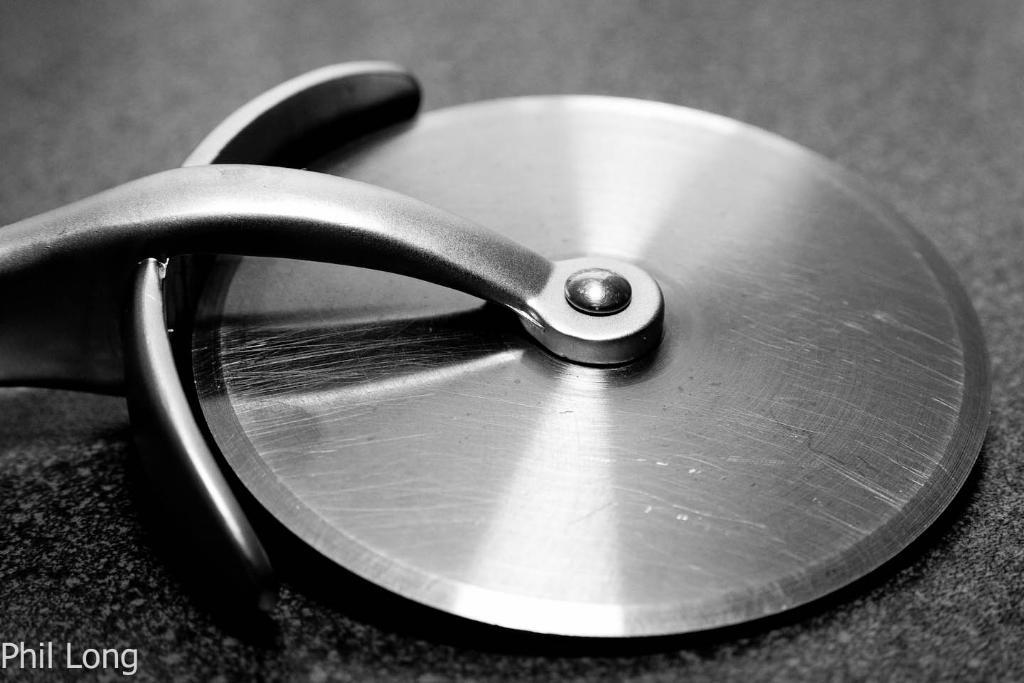What object can be seen in the image that is used for cutting pizza? There is a pizza cutter in the image. Is there any text or logo visible in the image? Yes, there is a watermark in the image. What color scheme is used in the image? The image is black and white in color. Is there any quicksand visible in the image? No, there is no quicksand present in the image. Can you see any crooks or criminals in the image? No, there are no crooks or criminals depicted in the image. 